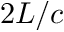<formula> <loc_0><loc_0><loc_500><loc_500>2 L / c</formula> 